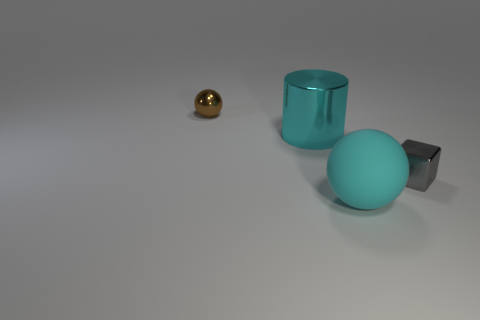Add 2 brown things. How many objects exist? 6 Subtract all cylinders. How many objects are left? 3 Subtract 0 blue blocks. How many objects are left? 4 Subtract all gray metal things. Subtract all large brown metallic objects. How many objects are left? 3 Add 1 blocks. How many blocks are left? 2 Add 2 cubes. How many cubes exist? 3 